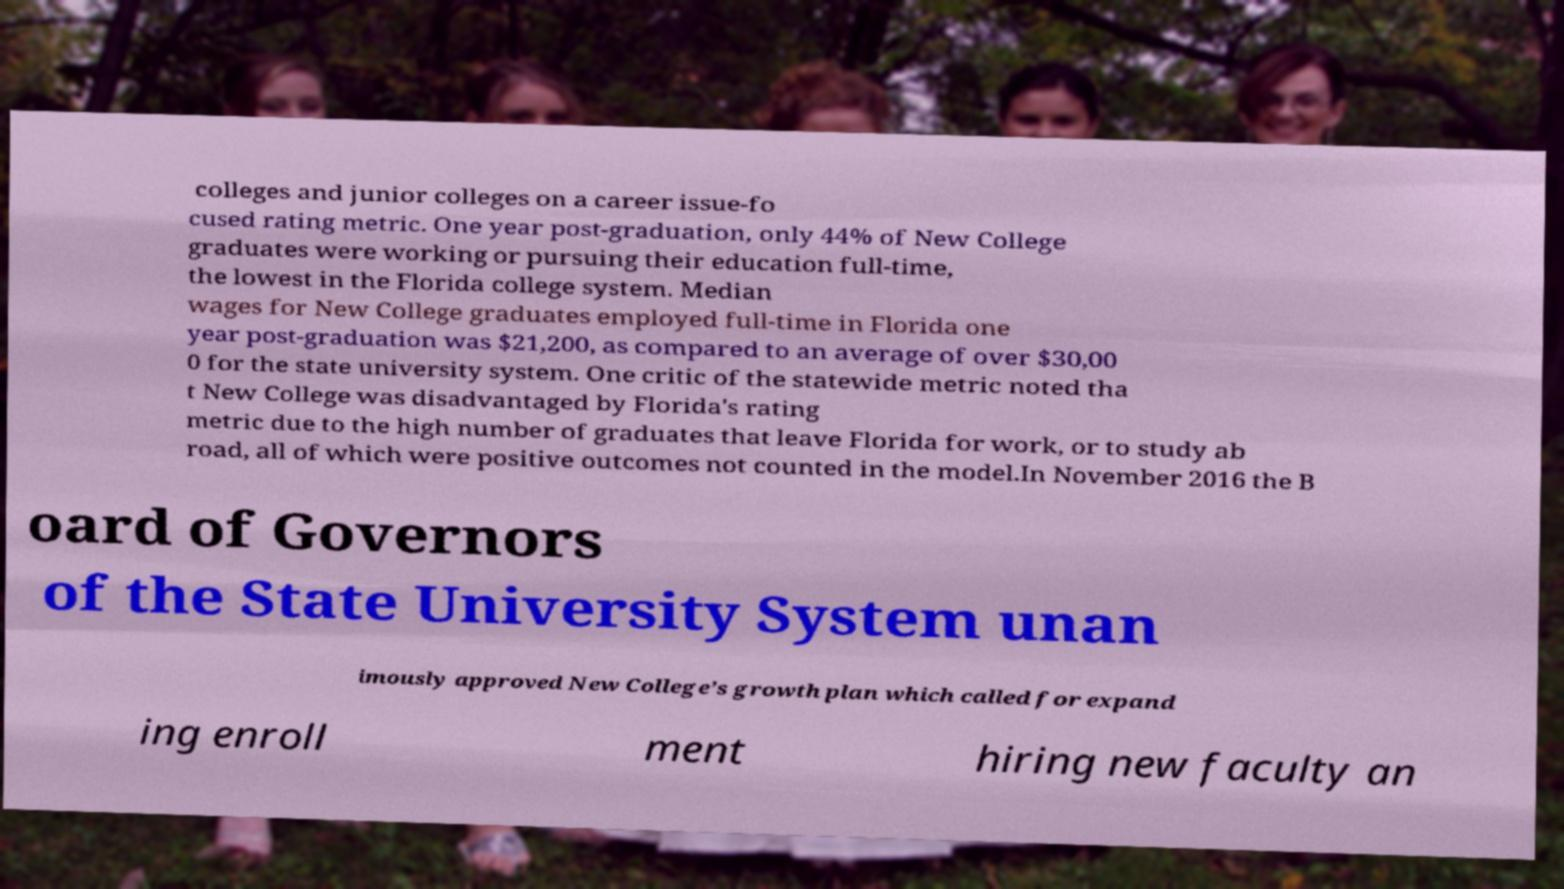Please read and relay the text visible in this image. What does it say? colleges and junior colleges on a career issue-fo cused rating metric. One year post-graduation, only 44% of New College graduates were working or pursuing their education full-time, the lowest in the Florida college system. Median wages for New College graduates employed full-time in Florida one year post-graduation was $21,200, as compared to an average of over $30,00 0 for the state university system. One critic of the statewide metric noted tha t New College was disadvantaged by Florida's rating metric due to the high number of graduates that leave Florida for work, or to study ab road, all of which were positive outcomes not counted in the model.In November 2016 the B oard of Governors of the State University System unan imously approved New College’s growth plan which called for expand ing enroll ment hiring new faculty an 